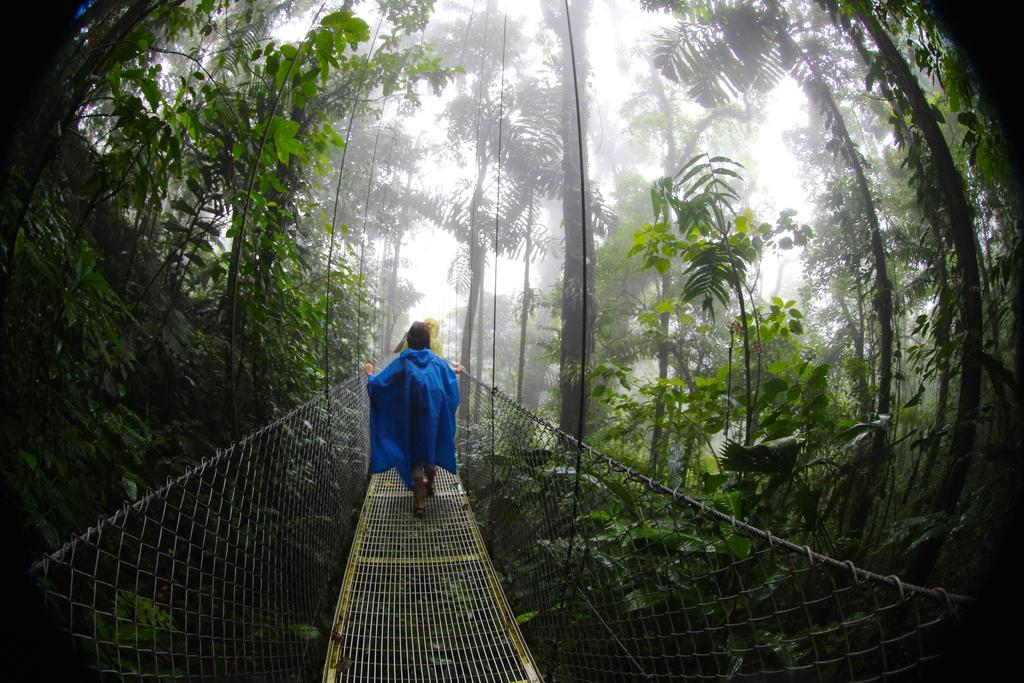What can be seen on the bridge in the image? There are people on the bridge in the image. What type of vegetation is present in the image? There are trees and plants in the image. What part of the natural environment is visible in the image? The sky is visible in the image. What level of expertise do the people on the bridge have in working with edge technology? There is no information about the people's expertise in edge technology in the image. What type of work are the people on the bridge doing? The image does not provide information about the people's work or activities. 